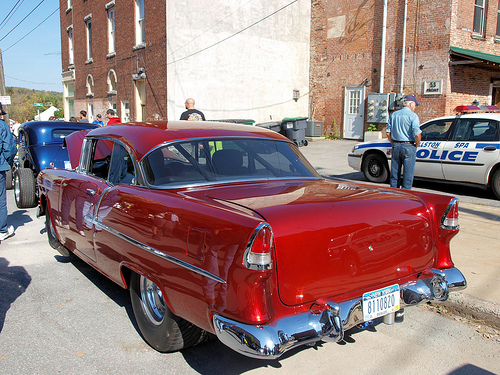<image>
Is there a man to the right of the trash can? Yes. From this viewpoint, the man is positioned to the right side relative to the trash can. Is there a man next to the utility pole? No. The man is not positioned next to the utility pole. They are located in different areas of the scene. 